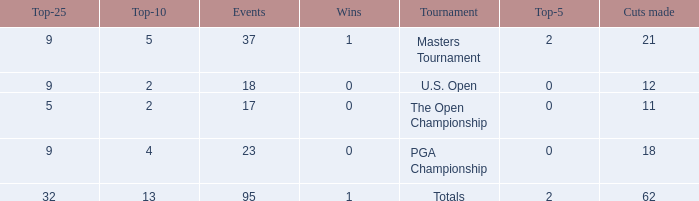What is the average number of cuts made in the Top 25 smaller than 5? None. 